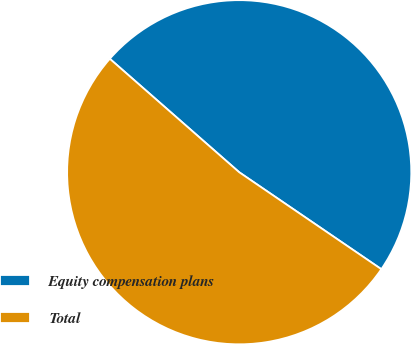Convert chart. <chart><loc_0><loc_0><loc_500><loc_500><pie_chart><fcel>Equity compensation plans<fcel>Total<nl><fcel>48.07%<fcel>51.93%<nl></chart> 